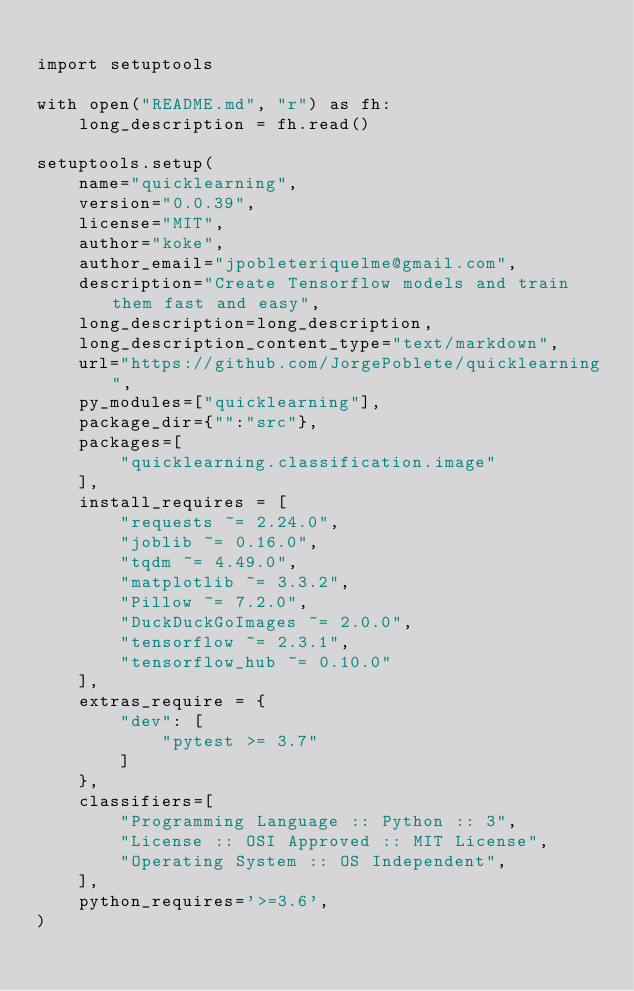<code> <loc_0><loc_0><loc_500><loc_500><_Python_>
import setuptools

with open("README.md", "r") as fh:
    long_description = fh.read()

setuptools.setup(
    name="quicklearning",
    version="0.0.39",
    license="MIT",
    author="koke",
    author_email="jpobleteriquelme@gmail.com",
    description="Create Tensorflow models and train them fast and easy",
    long_description=long_description,
    long_description_content_type="text/markdown",
    url="https://github.com/JorgePoblete/quicklearning",
    py_modules=["quicklearning"],
    package_dir={"":"src"},
    packages=[
        "quicklearning.classification.image"
    ],
    install_requires = [
        "requests ~= 2.24.0",
        "joblib ~= 0.16.0",
        "tqdm ~= 4.49.0",
        "matplotlib ~= 3.3.2",
        "Pillow ~= 7.2.0",
        "DuckDuckGoImages ~= 2.0.0",
        "tensorflow ~= 2.3.1",
        "tensorflow_hub ~= 0.10.0"
    ],
    extras_require = {
        "dev": [
            "pytest >= 3.7"
        ]
    },
    classifiers=[
        "Programming Language :: Python :: 3",
        "License :: OSI Approved :: MIT License",
        "Operating System :: OS Independent",
    ],
    python_requires='>=3.6',
) 
</code> 